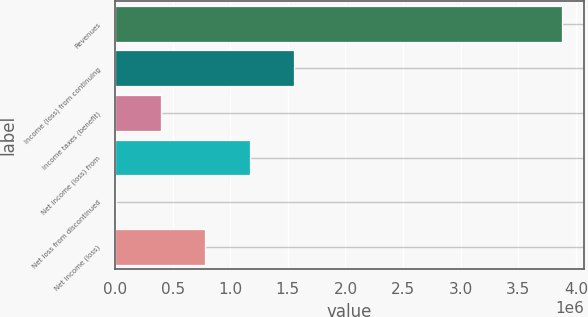Convert chart to OTSL. <chart><loc_0><loc_0><loc_500><loc_500><bar_chart><fcel>Revenues<fcel>Income (loss) from continuing<fcel>Income taxes (benefit)<fcel>Net income (loss) from<fcel>Net loss from discontinued<fcel>Net income (loss)<nl><fcel>3.87433e+06<fcel>1.55556e+06<fcel>396167<fcel>1.16909e+06<fcel>9704<fcel>782630<nl></chart> 